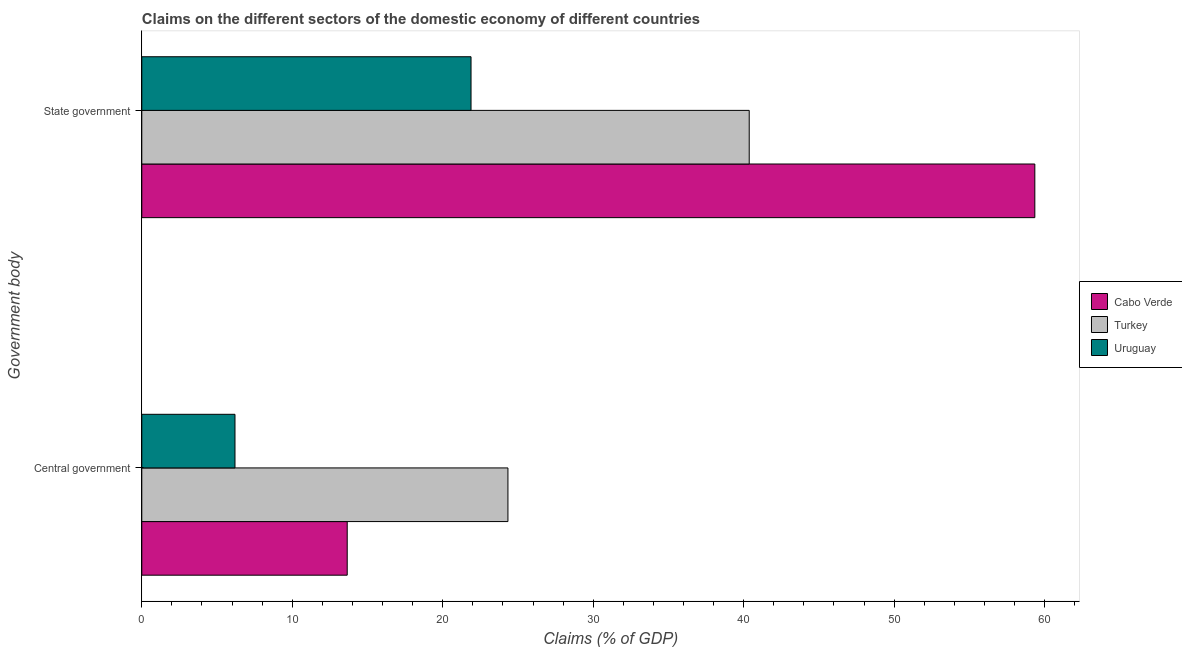How many groups of bars are there?
Offer a terse response. 2. Are the number of bars on each tick of the Y-axis equal?
Your answer should be very brief. Yes. How many bars are there on the 1st tick from the bottom?
Make the answer very short. 3. What is the label of the 2nd group of bars from the top?
Your response must be concise. Central government. What is the claims on state government in Cabo Verde?
Make the answer very short. 59.35. Across all countries, what is the maximum claims on state government?
Provide a succinct answer. 59.35. Across all countries, what is the minimum claims on central government?
Provide a short and direct response. 6.19. In which country was the claims on state government minimum?
Make the answer very short. Uruguay. What is the total claims on central government in the graph?
Your response must be concise. 44.18. What is the difference between the claims on central government in Cabo Verde and that in Uruguay?
Your answer should be compact. 7.46. What is the difference between the claims on central government in Uruguay and the claims on state government in Cabo Verde?
Ensure brevity in your answer.  -53.16. What is the average claims on state government per country?
Your answer should be compact. 40.53. What is the difference between the claims on state government and claims on central government in Turkey?
Provide a short and direct response. 16.04. What is the ratio of the claims on state government in Turkey to that in Uruguay?
Your answer should be compact. 1.84. In how many countries, is the claims on state government greater than the average claims on state government taken over all countries?
Your response must be concise. 1. What does the 1st bar from the top in State government represents?
Your answer should be compact. Uruguay. What does the 1st bar from the bottom in State government represents?
Provide a short and direct response. Cabo Verde. How many bars are there?
Give a very brief answer. 6. Are the values on the major ticks of X-axis written in scientific E-notation?
Offer a terse response. No. Does the graph contain any zero values?
Offer a terse response. No. Where does the legend appear in the graph?
Keep it short and to the point. Center right. What is the title of the graph?
Provide a succinct answer. Claims on the different sectors of the domestic economy of different countries. Does "High income: OECD" appear as one of the legend labels in the graph?
Offer a very short reply. No. What is the label or title of the X-axis?
Offer a very short reply. Claims (% of GDP). What is the label or title of the Y-axis?
Make the answer very short. Government body. What is the Claims (% of GDP) of Cabo Verde in Central government?
Provide a short and direct response. 13.65. What is the Claims (% of GDP) in Turkey in Central government?
Offer a very short reply. 24.33. What is the Claims (% of GDP) of Uruguay in Central government?
Provide a succinct answer. 6.19. What is the Claims (% of GDP) in Cabo Verde in State government?
Offer a terse response. 59.35. What is the Claims (% of GDP) of Turkey in State government?
Offer a very short reply. 40.37. What is the Claims (% of GDP) in Uruguay in State government?
Keep it short and to the point. 21.88. Across all Government body, what is the maximum Claims (% of GDP) in Cabo Verde?
Provide a short and direct response. 59.35. Across all Government body, what is the maximum Claims (% of GDP) in Turkey?
Ensure brevity in your answer.  40.37. Across all Government body, what is the maximum Claims (% of GDP) in Uruguay?
Keep it short and to the point. 21.88. Across all Government body, what is the minimum Claims (% of GDP) of Cabo Verde?
Give a very brief answer. 13.65. Across all Government body, what is the minimum Claims (% of GDP) of Turkey?
Give a very brief answer. 24.33. Across all Government body, what is the minimum Claims (% of GDP) in Uruguay?
Provide a short and direct response. 6.19. What is the total Claims (% of GDP) of Cabo Verde in the graph?
Ensure brevity in your answer.  73. What is the total Claims (% of GDP) in Turkey in the graph?
Provide a short and direct response. 64.7. What is the total Claims (% of GDP) of Uruguay in the graph?
Your answer should be compact. 28.07. What is the difference between the Claims (% of GDP) in Cabo Verde in Central government and that in State government?
Ensure brevity in your answer.  -45.7. What is the difference between the Claims (% of GDP) of Turkey in Central government and that in State government?
Provide a succinct answer. -16.04. What is the difference between the Claims (% of GDP) in Uruguay in Central government and that in State government?
Keep it short and to the point. -15.69. What is the difference between the Claims (% of GDP) in Cabo Verde in Central government and the Claims (% of GDP) in Turkey in State government?
Provide a short and direct response. -26.72. What is the difference between the Claims (% of GDP) in Cabo Verde in Central government and the Claims (% of GDP) in Uruguay in State government?
Keep it short and to the point. -8.23. What is the difference between the Claims (% of GDP) of Turkey in Central government and the Claims (% of GDP) of Uruguay in State government?
Ensure brevity in your answer.  2.45. What is the average Claims (% of GDP) in Cabo Verde per Government body?
Your answer should be very brief. 36.5. What is the average Claims (% of GDP) of Turkey per Government body?
Provide a short and direct response. 32.35. What is the average Claims (% of GDP) of Uruguay per Government body?
Provide a succinct answer. 14.04. What is the difference between the Claims (% of GDP) of Cabo Verde and Claims (% of GDP) of Turkey in Central government?
Provide a short and direct response. -10.68. What is the difference between the Claims (% of GDP) in Cabo Verde and Claims (% of GDP) in Uruguay in Central government?
Make the answer very short. 7.46. What is the difference between the Claims (% of GDP) of Turkey and Claims (% of GDP) of Uruguay in Central government?
Your answer should be very brief. 18.14. What is the difference between the Claims (% of GDP) in Cabo Verde and Claims (% of GDP) in Turkey in State government?
Ensure brevity in your answer.  18.98. What is the difference between the Claims (% of GDP) in Cabo Verde and Claims (% of GDP) in Uruguay in State government?
Provide a short and direct response. 37.47. What is the difference between the Claims (% of GDP) of Turkey and Claims (% of GDP) of Uruguay in State government?
Offer a terse response. 18.49. What is the ratio of the Claims (% of GDP) in Cabo Verde in Central government to that in State government?
Give a very brief answer. 0.23. What is the ratio of the Claims (% of GDP) of Turkey in Central government to that in State government?
Your answer should be very brief. 0.6. What is the ratio of the Claims (% of GDP) in Uruguay in Central government to that in State government?
Offer a very short reply. 0.28. What is the difference between the highest and the second highest Claims (% of GDP) in Cabo Verde?
Your answer should be very brief. 45.7. What is the difference between the highest and the second highest Claims (% of GDP) of Turkey?
Offer a very short reply. 16.04. What is the difference between the highest and the second highest Claims (% of GDP) of Uruguay?
Provide a short and direct response. 15.69. What is the difference between the highest and the lowest Claims (% of GDP) of Cabo Verde?
Offer a very short reply. 45.7. What is the difference between the highest and the lowest Claims (% of GDP) in Turkey?
Your answer should be very brief. 16.04. What is the difference between the highest and the lowest Claims (% of GDP) in Uruguay?
Make the answer very short. 15.69. 